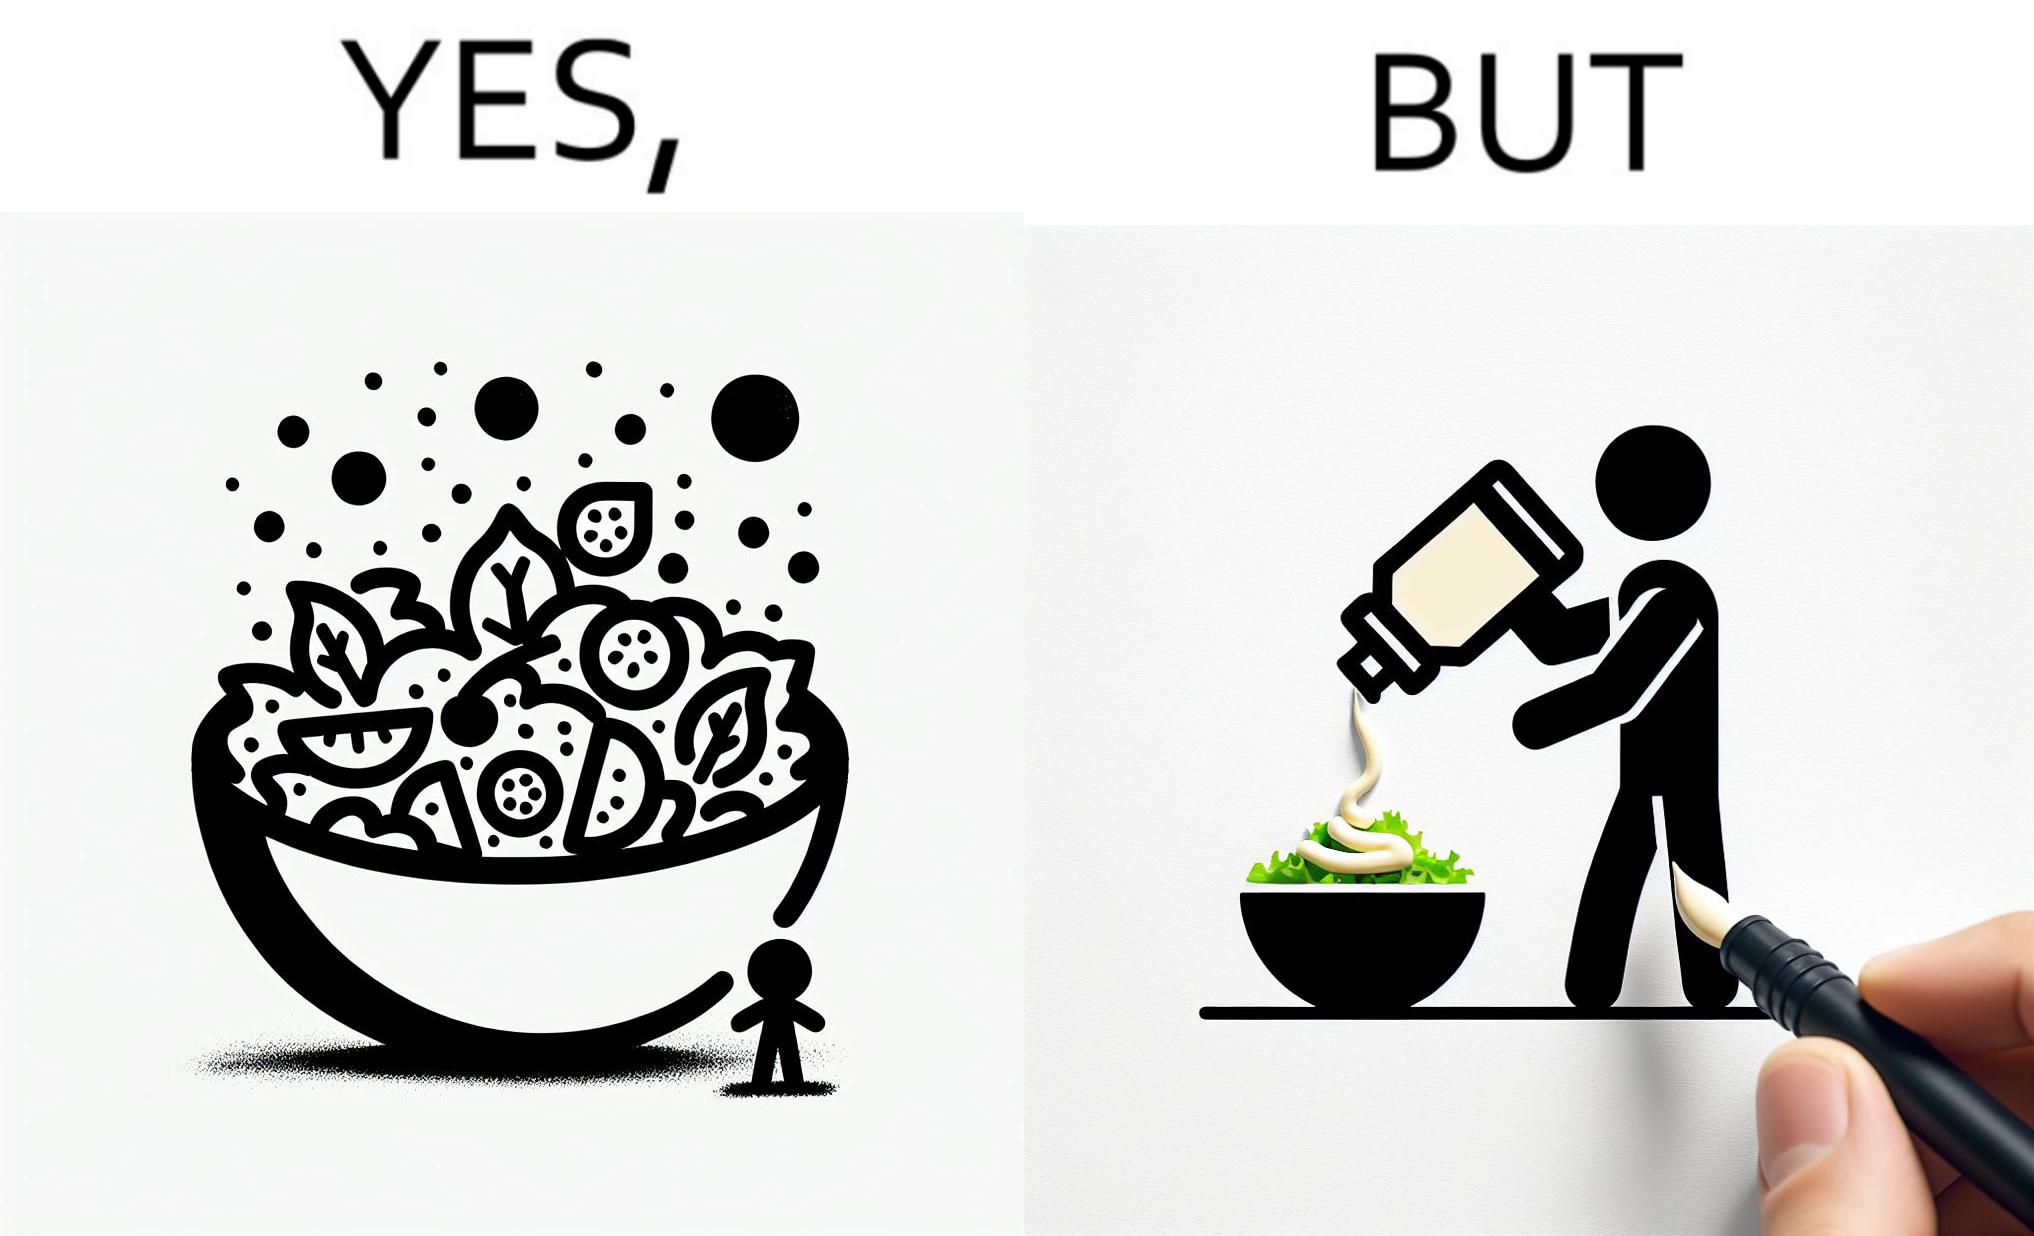What is shown in the left half versus the right half of this image? In the left part of the image: salad in a bowl In the right part of the image: pouring mayonnaise sauce on salad in a bowl 